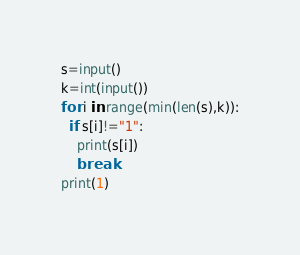<code> <loc_0><loc_0><loc_500><loc_500><_Python_>s=input()
k=int(input())
for i in range(min(len(s),k)):
  if s[i]!="1":
    print(s[i])
    break
print(1)
</code> 